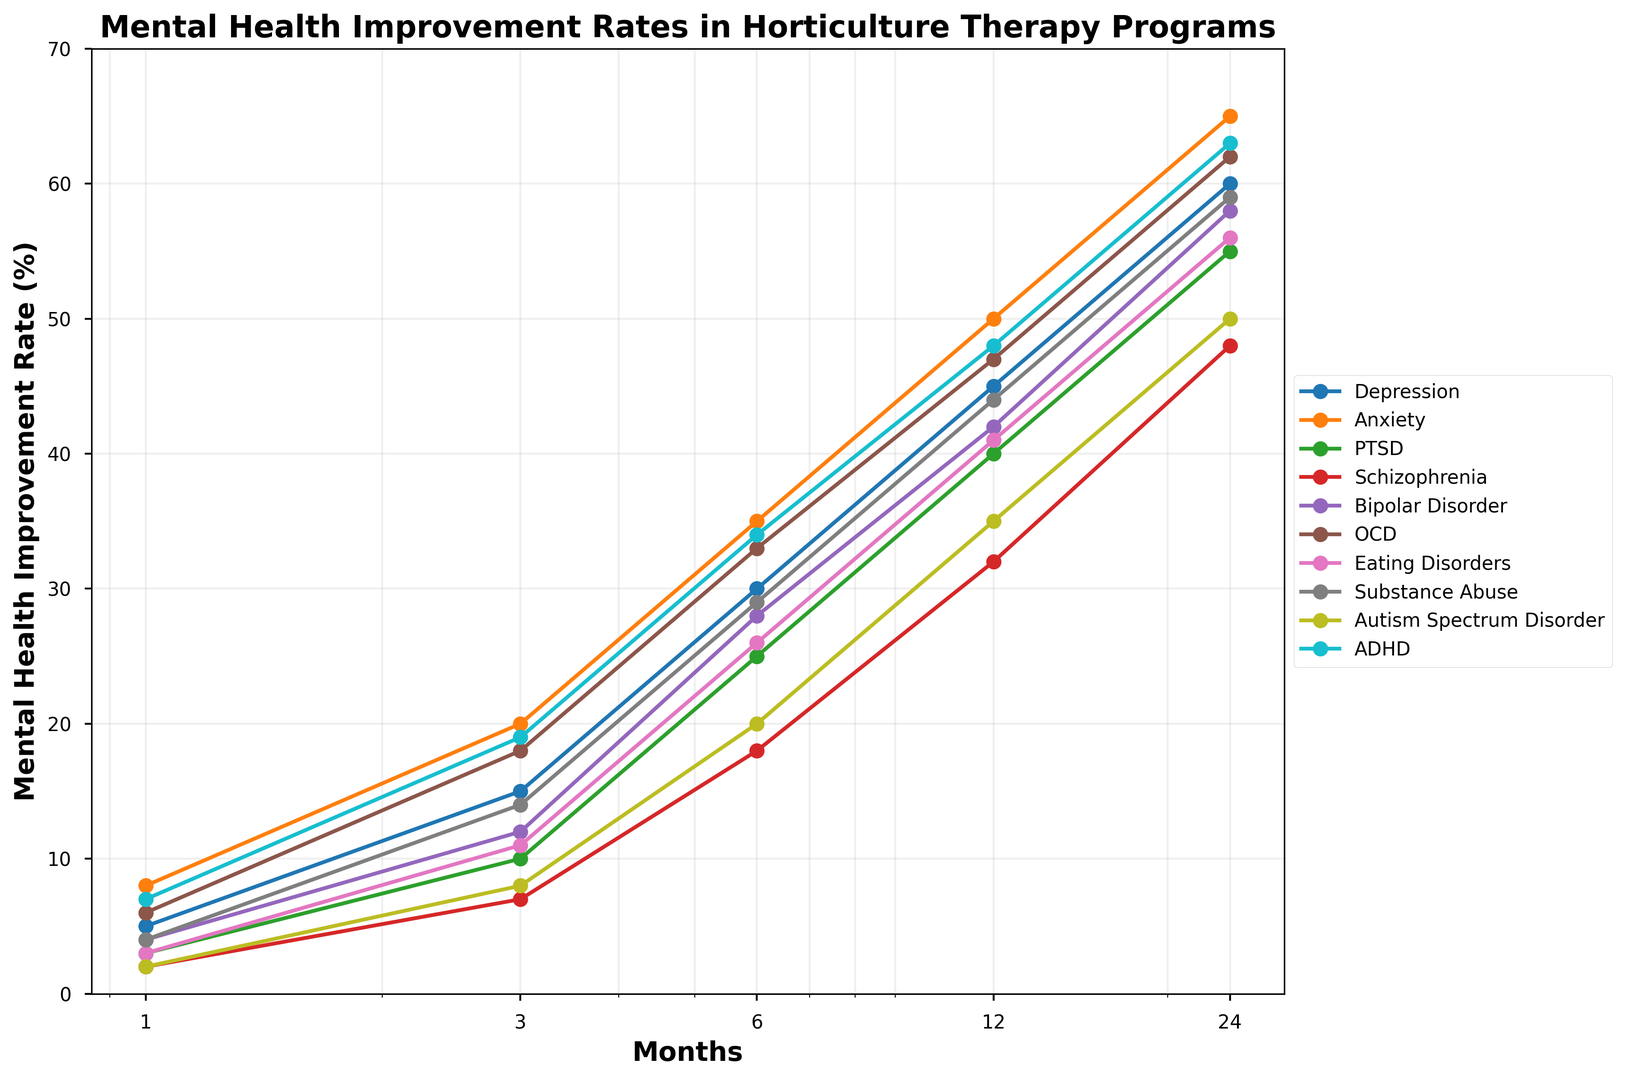Which disorder shows the highest improvement rate at 24 months? Look at the endpoint of each line on the rightmost part of the graph at 24 months. The highest endpoint corresponds to the disorder with the highest improvement rate.
Answer: Anxiety How does the improvement rate of PTSD at 6 months compare to that of ADHD at 6 months? Find the points corresponding to 6 months for PTSD and ADHD. Compare their y-values to see which is higher.
Answer: ADHD is higher What is the average improvement rate at 12 months for Depression and Bipolar Disorder? Find the points at 12 months for both disorders, sum their values and divide by 2: (45 (Depression) + 42 (Bipolar Disorder)) / 2 = 43.5
Answer: 43.5 Which disorder has the lowest improvement rate at 1 month? Look at the leftmost points (1 month) and identify the lowest one.
Answer: Schizophrenia By how much does the improvement rate of OCD increase from 1 month to 3 months? Find the values for OCD at 1 month and at 3 months and subtract the former from the latter: 18 (3 Months) − 6 (1 Month) = 12
Answer: 12 Which two disorders have the closest improvement rates at 12 months? Compare the y-values at 12 months for all disorders and identify the two closest values.
Answer: Depression and Bipolar Disorder What is the range of improvement rates for Substance Abuse over the presented time period? Identify the highest and lowest improvement rates for Substance Abuse: Max is 59 (24 Months), Min is 4 (1 Month). Range = 59 − 4 = 55
Answer: 55 How much does the improvement rate of Schizophrenia at 24 months exceed the rate at 12 months? Find the values at 24 months and at 12 months for Schizophrenia and subtract the latter from the former: 48 (24 Months) − 32 (12 Months) = 16
Answer: 16 Which disorder shows a steady increase in improvement rate over time without any decrease? Identify the disorder whose trend line consistently moves upwards without any dips.
Answer: All disorders Are the improvement rates for Autism Spectrum Disorder and ADHD closer at 1 month or at 6 months? Compare the distances between the points for Autism Spectrum Disorder and ADHD at both 1 month and 6 months.
Answer: Closer at 6 months 